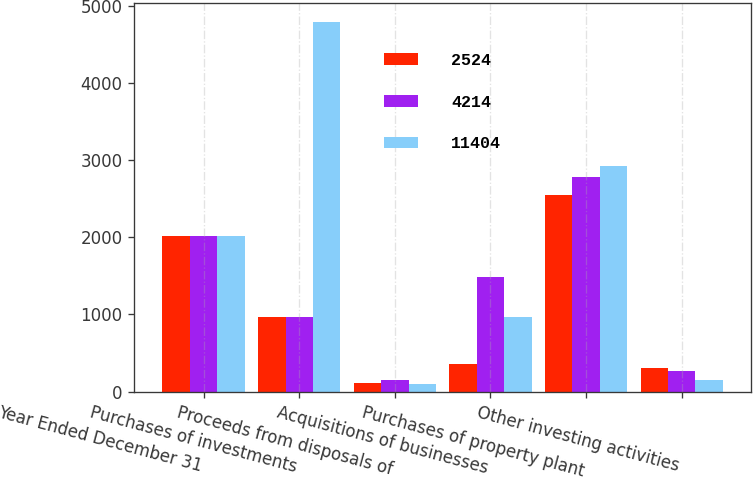Convert chart. <chart><loc_0><loc_0><loc_500><loc_500><stacked_bar_chart><ecel><fcel>Year Ended December 31<fcel>Purchases of investments<fcel>Proceeds from disposals of<fcel>Acquisitions of businesses<fcel>Purchases of property plant<fcel>Other investing activities<nl><fcel>2524<fcel>2013<fcel>971<fcel>111<fcel>353<fcel>2550<fcel>303<nl><fcel>4214<fcel>2012<fcel>971<fcel>143<fcel>1486<fcel>2780<fcel>268<nl><fcel>11404<fcel>2011<fcel>4798<fcel>101<fcel>971<fcel>2920<fcel>145<nl></chart> 